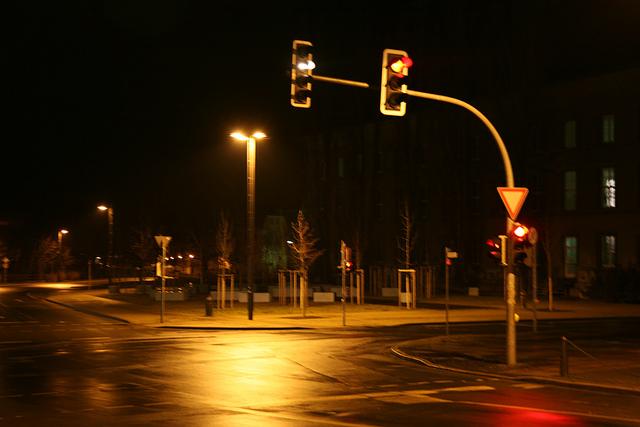How many cars are on the road?
Write a very short answer. 0. How many traffic lights can be seen?
Quick response, please. 3. Is this shot in focus?
Be succinct. Yes. When was this scene photographed?
Quick response, please. Night. 